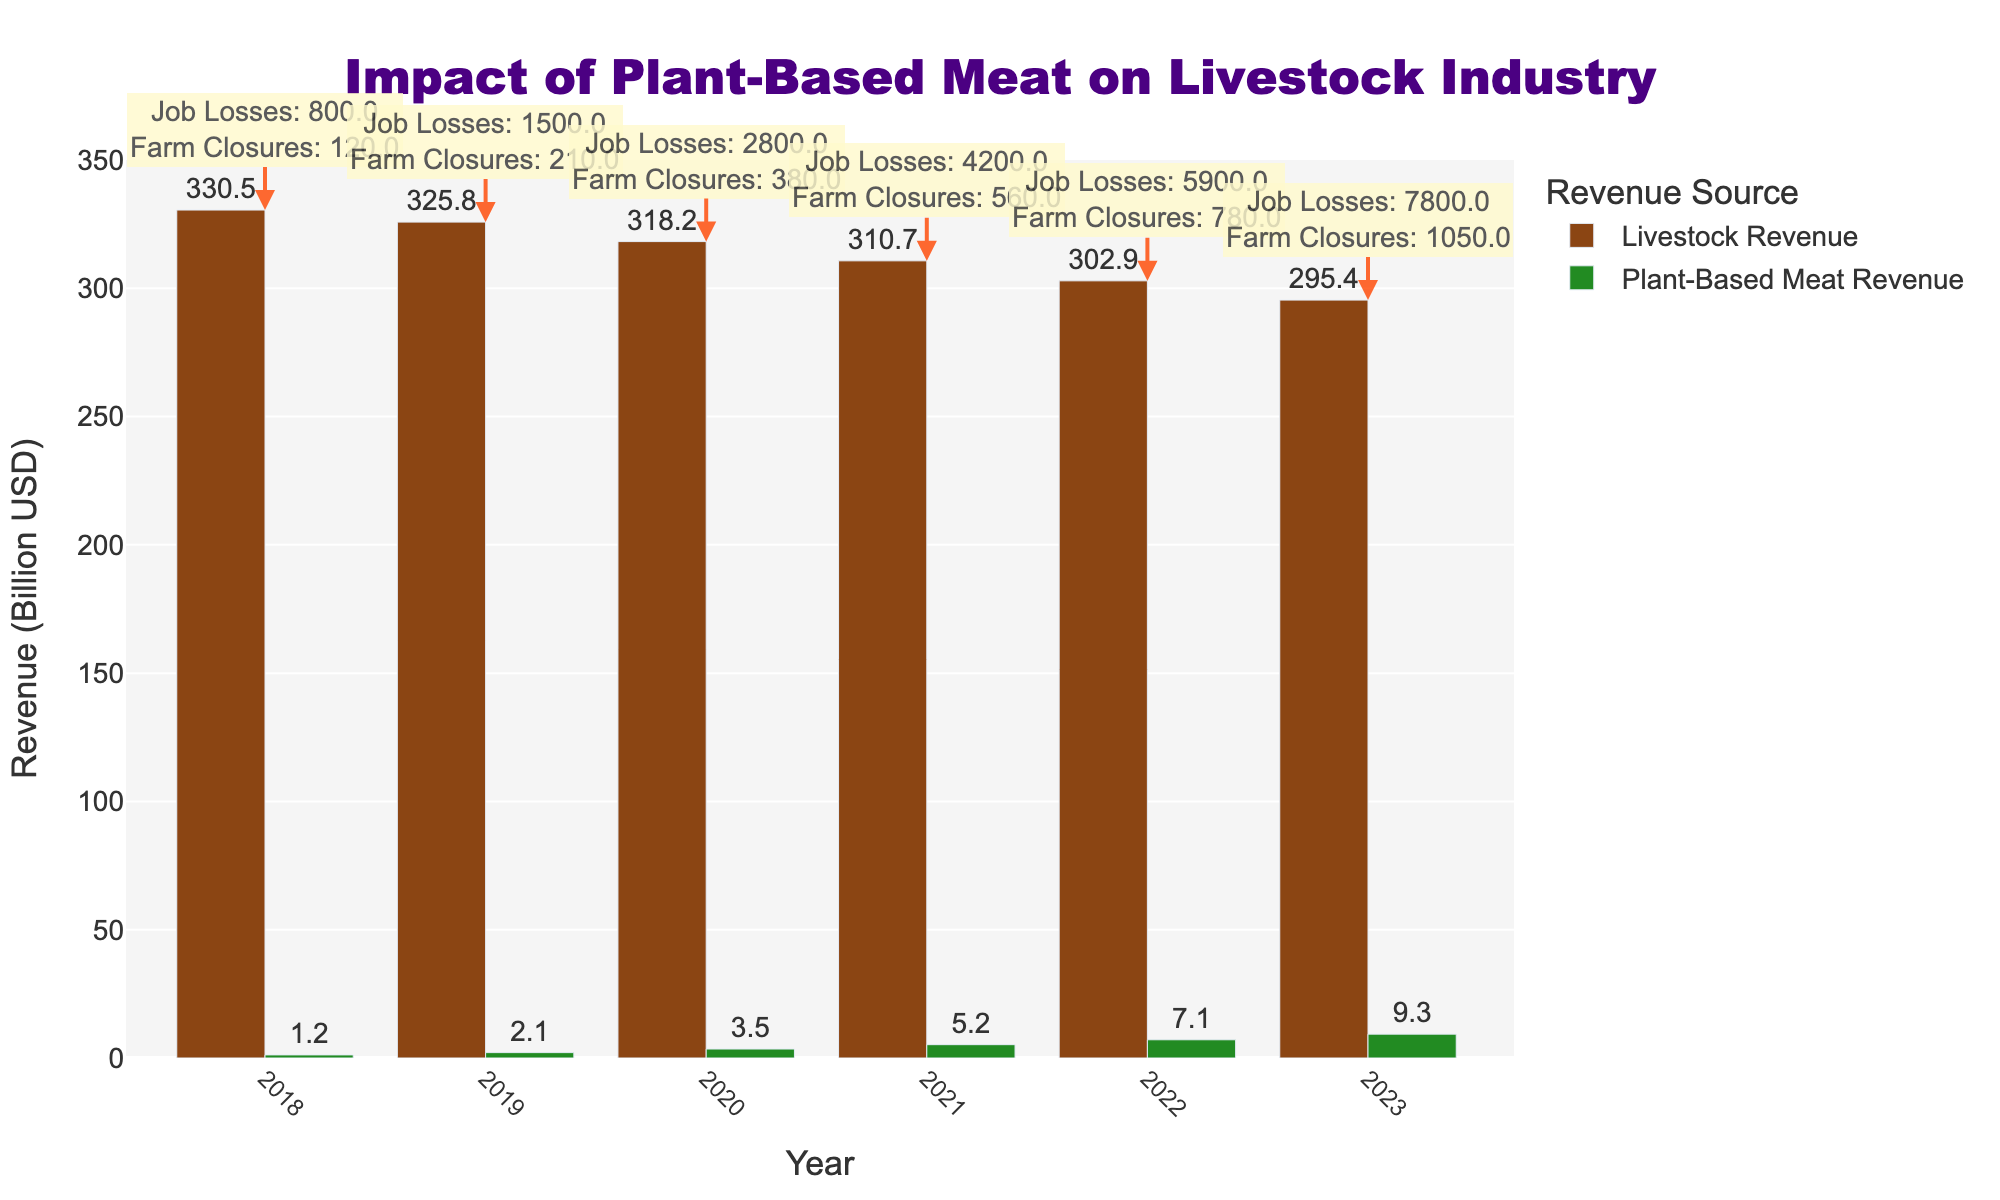What is the revenue difference between Livestock and Plant-Based Meat in 2023? In 2023, the Livestock Revenue is 295.4 billion USD, and the Plant-Based Meat Revenue is 9.3 billion USD. The difference is 295.4 - 9.3 = 286.1 billion USD.
Answer: 286.1 billion USD How has the revenue of the Livestock sector changed from 2018 to 2023? The Livestock Revenue in 2018 was 330.5 billion USD, and it was 295.4 billion USD in 2023. The change is 330.5 - 295.4 = 35.1 billion USD decrease.
Answer: 35.1 billion USD decrease Which year experienced the highest number of job losses in the Livestock sector? The annotations in the figure indicate the number of job losses for each year. The year 2023 experienced the highest number, with 7800 job losses.
Answer: 2023 What was the average revenue for the Plant-Based Meat industry from 2018 to 2023? Add up the Plant-Based Meat revenues from 2018 to 2023 and divide by the number of years: (1.2 + 2.1 + 3.5 + 5.2 + 7.1 + 9.3) / 6 = 28.4 / 6 = approximately 4.73 billion USD.
Answer: approximately 4.73 billion USD In which year did the Livestock sector experience the largest increase in farm closures from the previous year? The farm closures for each year are: 2018 (120), 2019 (210), 2020 (380), 2021 (560), 2022 (780), 2023 (1050). The largest increase occurred from 2021 to 2022 with an increase of 220 farm closures (780 - 560).
Answer: 2021 to 2022 Compared to 2019, how much more revenue did the Plant-Based Meat industry make in 2022? The Plant-Based Meat Revenue in 2019 was 2.1 billion USD, and in 2022 it was 7.1 billion USD. The increase is 7.1 - 2.1 = 5.0 billion USD.
Answer: 5.0 billion USD Which industry had a greater positive growth rate over the years shown, and what was the start and end range? The Plant-Based Meat industry had a greater positive growth rate. It started at 1.2 billion USD in 2018 and ended at 9.3 billion USD in 2023. In contrast, the Livestock Revenue declined over the same period.
Answer: Plant-Based Meat industry Visually compare the height of the bars for the Livestock Revenue and Plant-Based Meat Revenue in 2022. Which one is taller and by how much? In 2022, the Livestock bar is taller than the Plant-Based Meat bar. The Livestock Revenue is 302.9 billion USD, and the Plant-Based Meat Revenue is 7.1 billion USD. The difference is 302.9 - 7.1 = 295.8 billion USD.
Answer: Livestock bar, 295.8 billion USD What is the trend of Livestock Revenue over the years shown in the chart? The trend of Livestock Revenue is a steady decline from 330.5 billion USD in 2018 to 295.4 billion USD in 2023, indicating a continuous decrease each year.
Answer: Steady decline How many farm closures occurred in total from 2018 to 2023? Add the number of farm closures for each year: 120 + 210 + 380 + 560 + 780 + 1050 = 3100 farm closures.
Answer: 3100 farm closures 